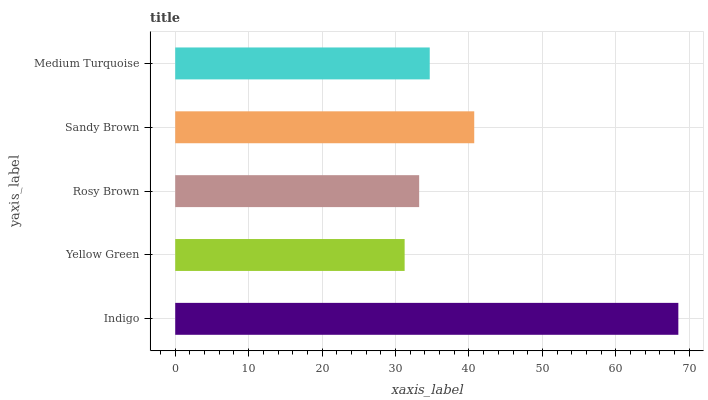Is Yellow Green the minimum?
Answer yes or no. Yes. Is Indigo the maximum?
Answer yes or no. Yes. Is Rosy Brown the minimum?
Answer yes or no. No. Is Rosy Brown the maximum?
Answer yes or no. No. Is Rosy Brown greater than Yellow Green?
Answer yes or no. Yes. Is Yellow Green less than Rosy Brown?
Answer yes or no. Yes. Is Yellow Green greater than Rosy Brown?
Answer yes or no. No. Is Rosy Brown less than Yellow Green?
Answer yes or no. No. Is Medium Turquoise the high median?
Answer yes or no. Yes. Is Medium Turquoise the low median?
Answer yes or no. Yes. Is Sandy Brown the high median?
Answer yes or no. No. Is Sandy Brown the low median?
Answer yes or no. No. 